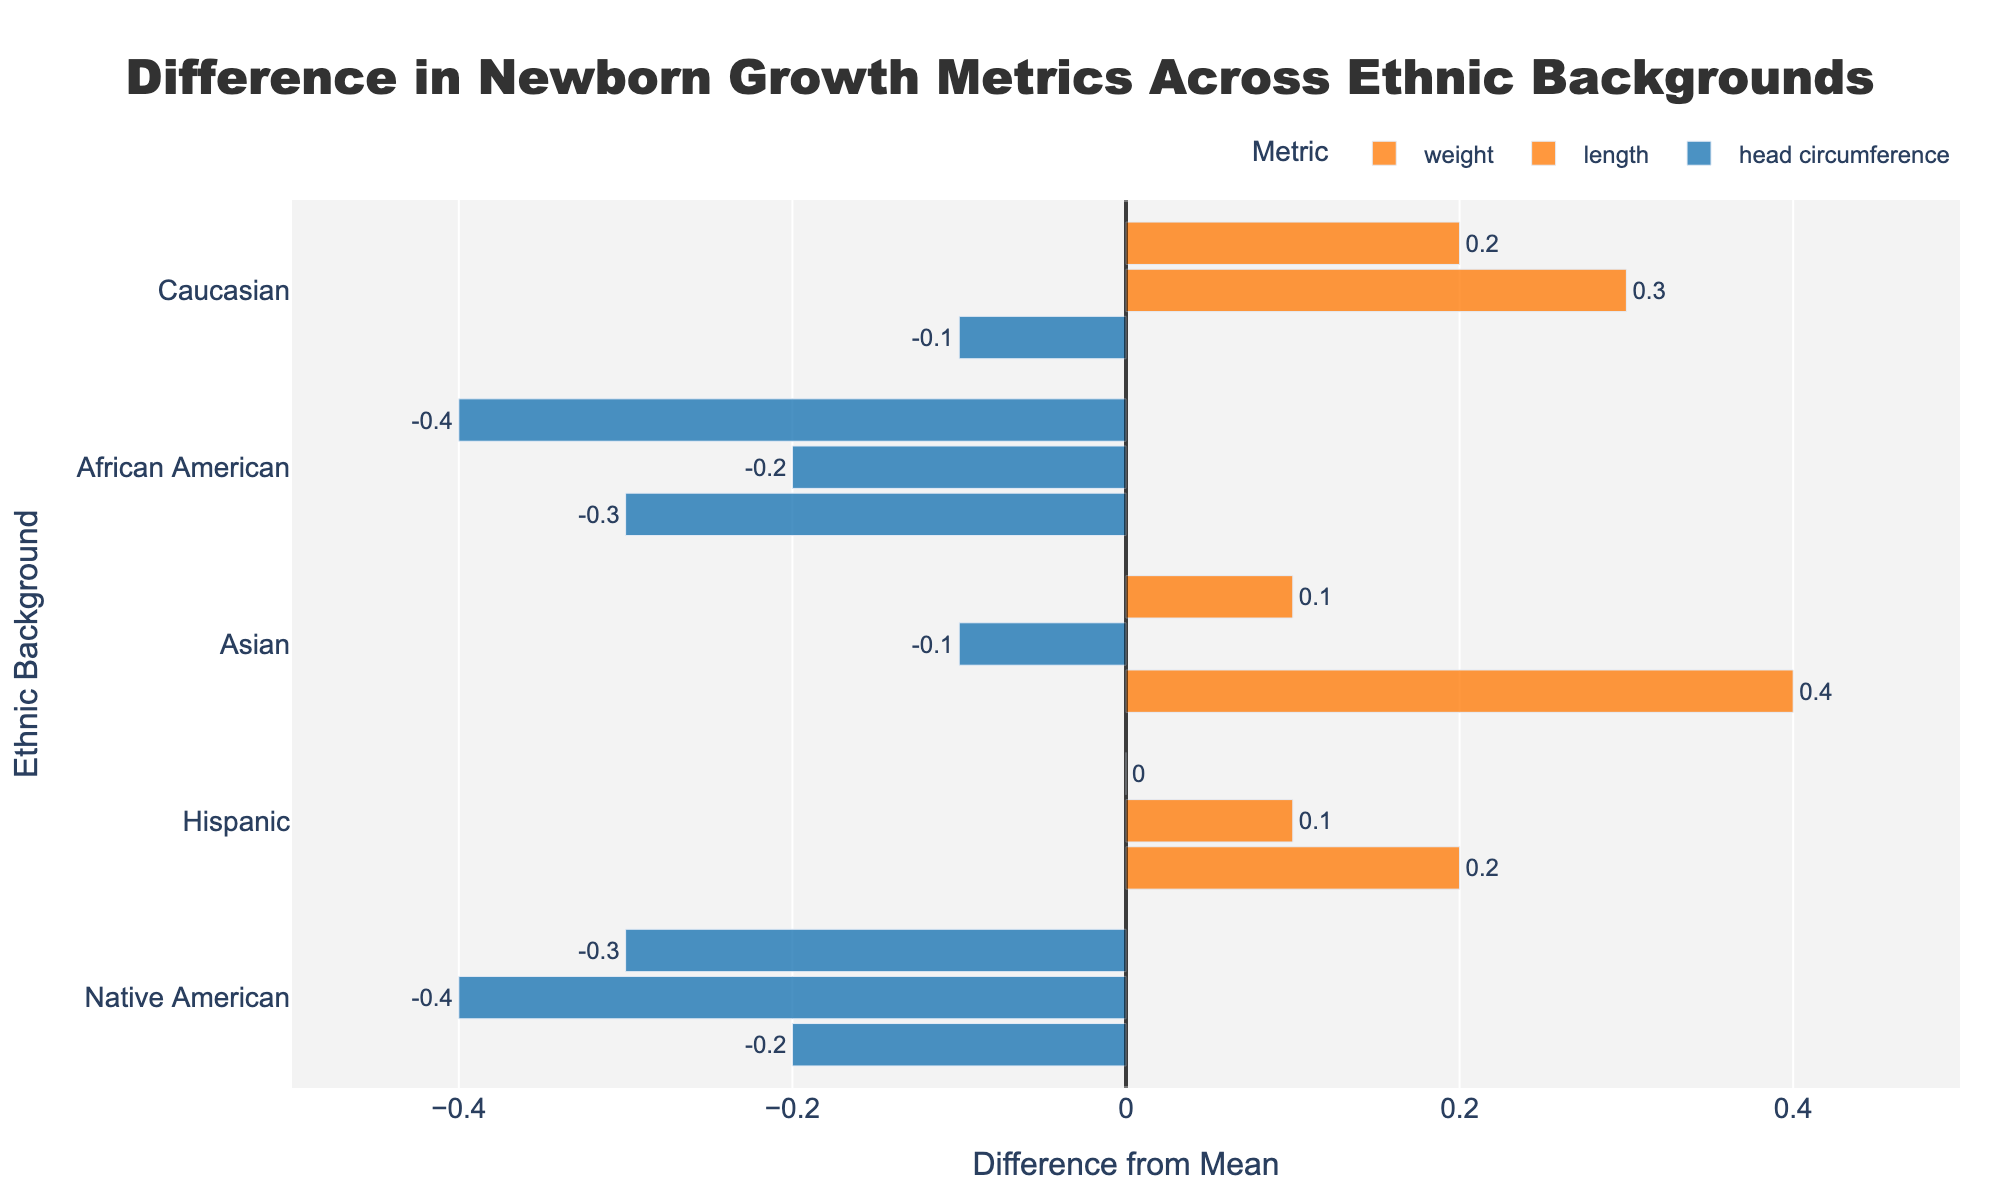What's the ethnic background with the highest positive difference in newborn head circumference? From the plot, Asian ethnicity has the highest positive difference in head circumference at 0.4.
Answer: Asian Which ethnic background shows the greatest negative difference in newborn weight? African American ethnicity shows the greatest negative difference in weight at -0.4 in the plot.
Answer: African American Compare the difference in length between Caucasian and Native American newborns. Which group has a higher difference from the mean? In the plot, Caucasian newborns have a difference in length of 0.3, while Native American newborns have a difference of -0.4. 0.3 is higher than -0.4.
Answer: Caucasian Which metric shows the smallest difference from the mean for Hispanic newborns? For Hispanic newborns, weight shows the smallest difference from the mean at 0.0 according to the plot.
Answer: weight Calculate the average difference from the mean for African American newborns across all metrics. From the plot, the differences for African American newborns are: weight -0.4, length -0.2, head circumference -0.3. The sum is -0.4 - 0.2 - 0.3 = -0.9 and the average is -0.9 / 3 = -0.3.
Answer: -0.3 Which metric for Asian newborns indicates a higher difference from the mean: weight or head circumference? From the plot, head circumference for Asian newborns shows a difference of 0.4, while weight shows a difference of 0.1. 0.4 is higher than 0.1.
Answer: head circumference What is the range of differences from the mean for Native American newborns across all metrics? From the plot, the differences for Native American newborns are: weight -0.3, length -0.4, head circumference -0.2. The range is the difference between the maximum and minimum values: -0.2 - (-0.4) = 0.2.
Answer: 0.2 